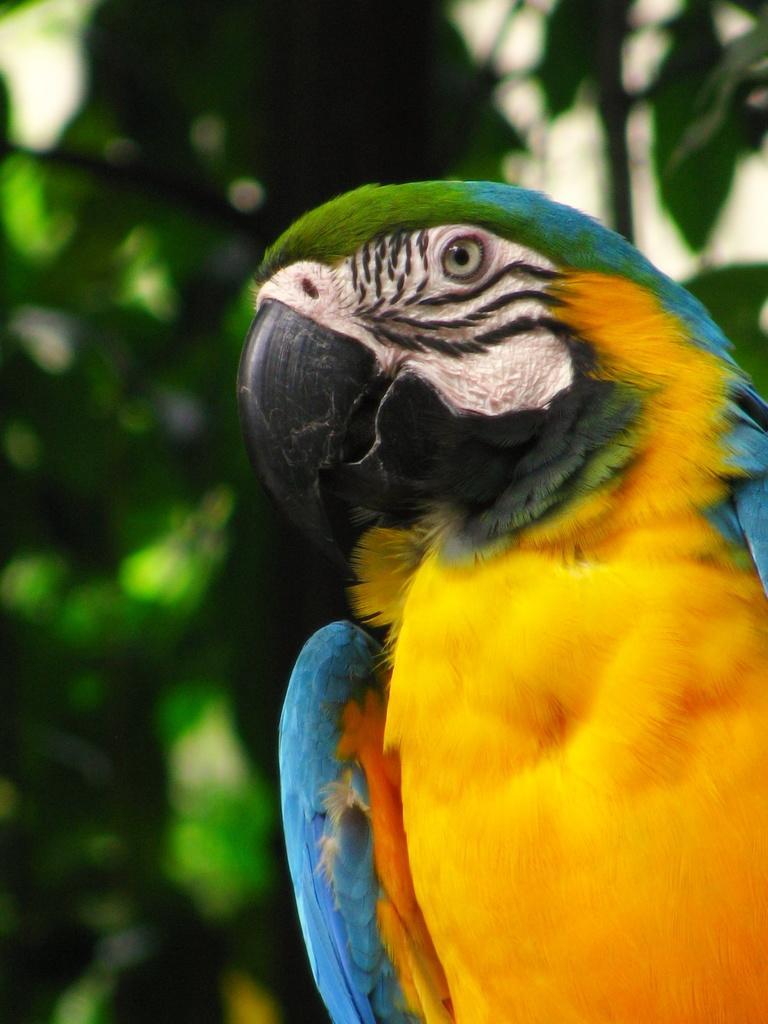Please provide a concise description of this image. In this image we can see a multicolored parrot, and in background we can see some plants. 